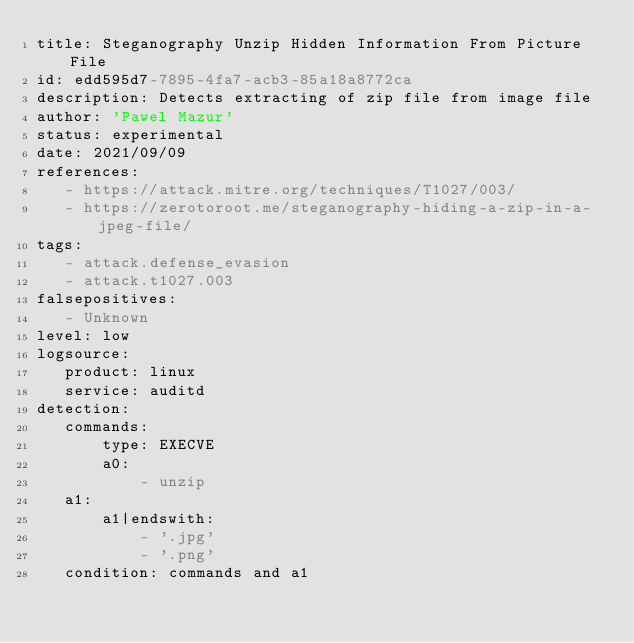Convert code to text. <code><loc_0><loc_0><loc_500><loc_500><_YAML_>title: Steganography Unzip Hidden Information From Picture File
id: edd595d7-7895-4fa7-acb3-85a18a8772ca
description: Detects extracting of zip file from image file
author: 'Pawel Mazur'
status: experimental
date: 2021/09/09
references:
   - https://attack.mitre.org/techniques/T1027/003/
   - https://zerotoroot.me/steganography-hiding-a-zip-in-a-jpeg-file/
tags:
   - attack.defense_evasion
   - attack.t1027.003
falsepositives:
   - Unknown
level: low
logsource:
   product: linux
   service: auditd
detection:
   commands:
       type: EXECVE
       a0:
           - unzip
   a1:
       a1|endswith:
           - '.jpg'
           - '.png'
   condition: commands and a1
</code> 